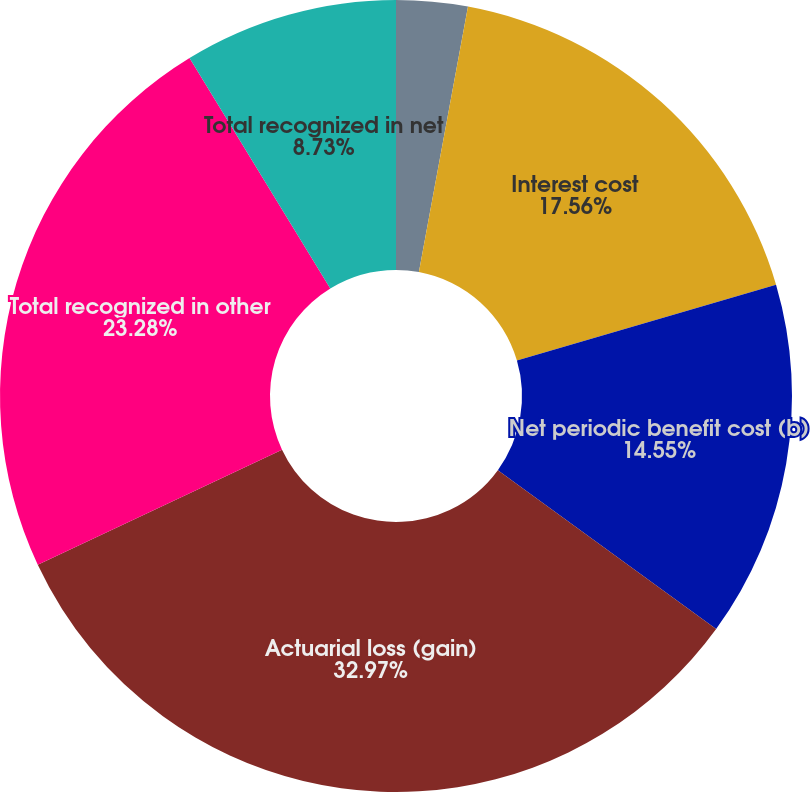<chart> <loc_0><loc_0><loc_500><loc_500><pie_chart><fcel>Service cost<fcel>Interest cost<fcel>Net periodic benefit cost (b)<fcel>Actuarial loss (gain)<fcel>Total recognized in other<fcel>Total recognized in net<nl><fcel>2.91%<fcel>17.56%<fcel>14.55%<fcel>32.98%<fcel>23.28%<fcel>8.73%<nl></chart> 